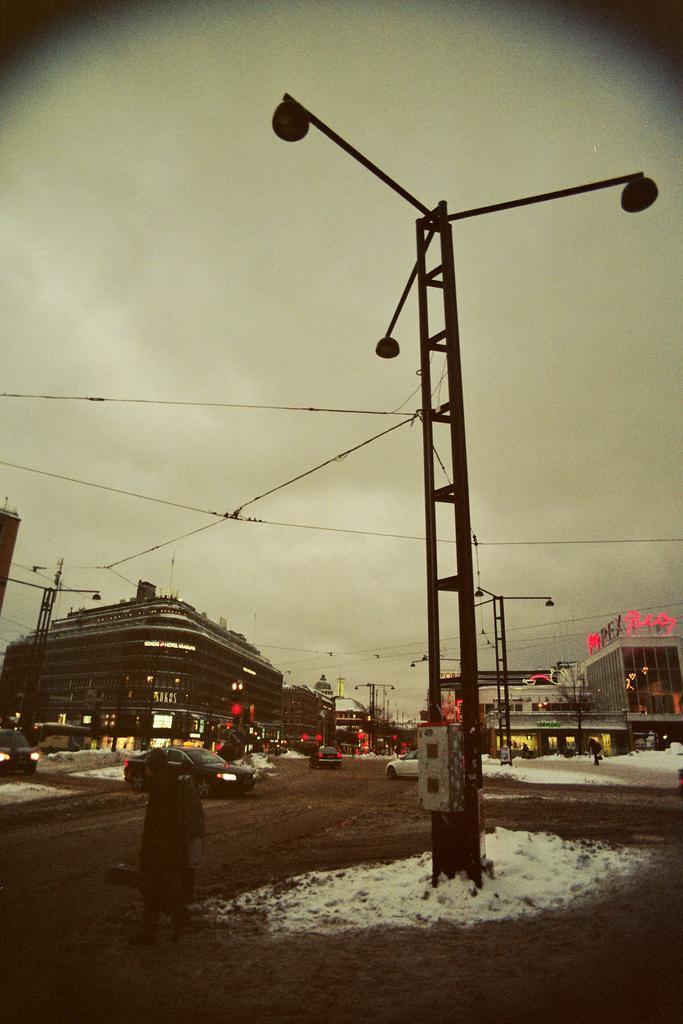Describe this image in one or two sentences. In this image there are poles and buildings. We can see lights. At the bottom there is a person and we can see cars. There is snow. In the background there are wires and sky. 